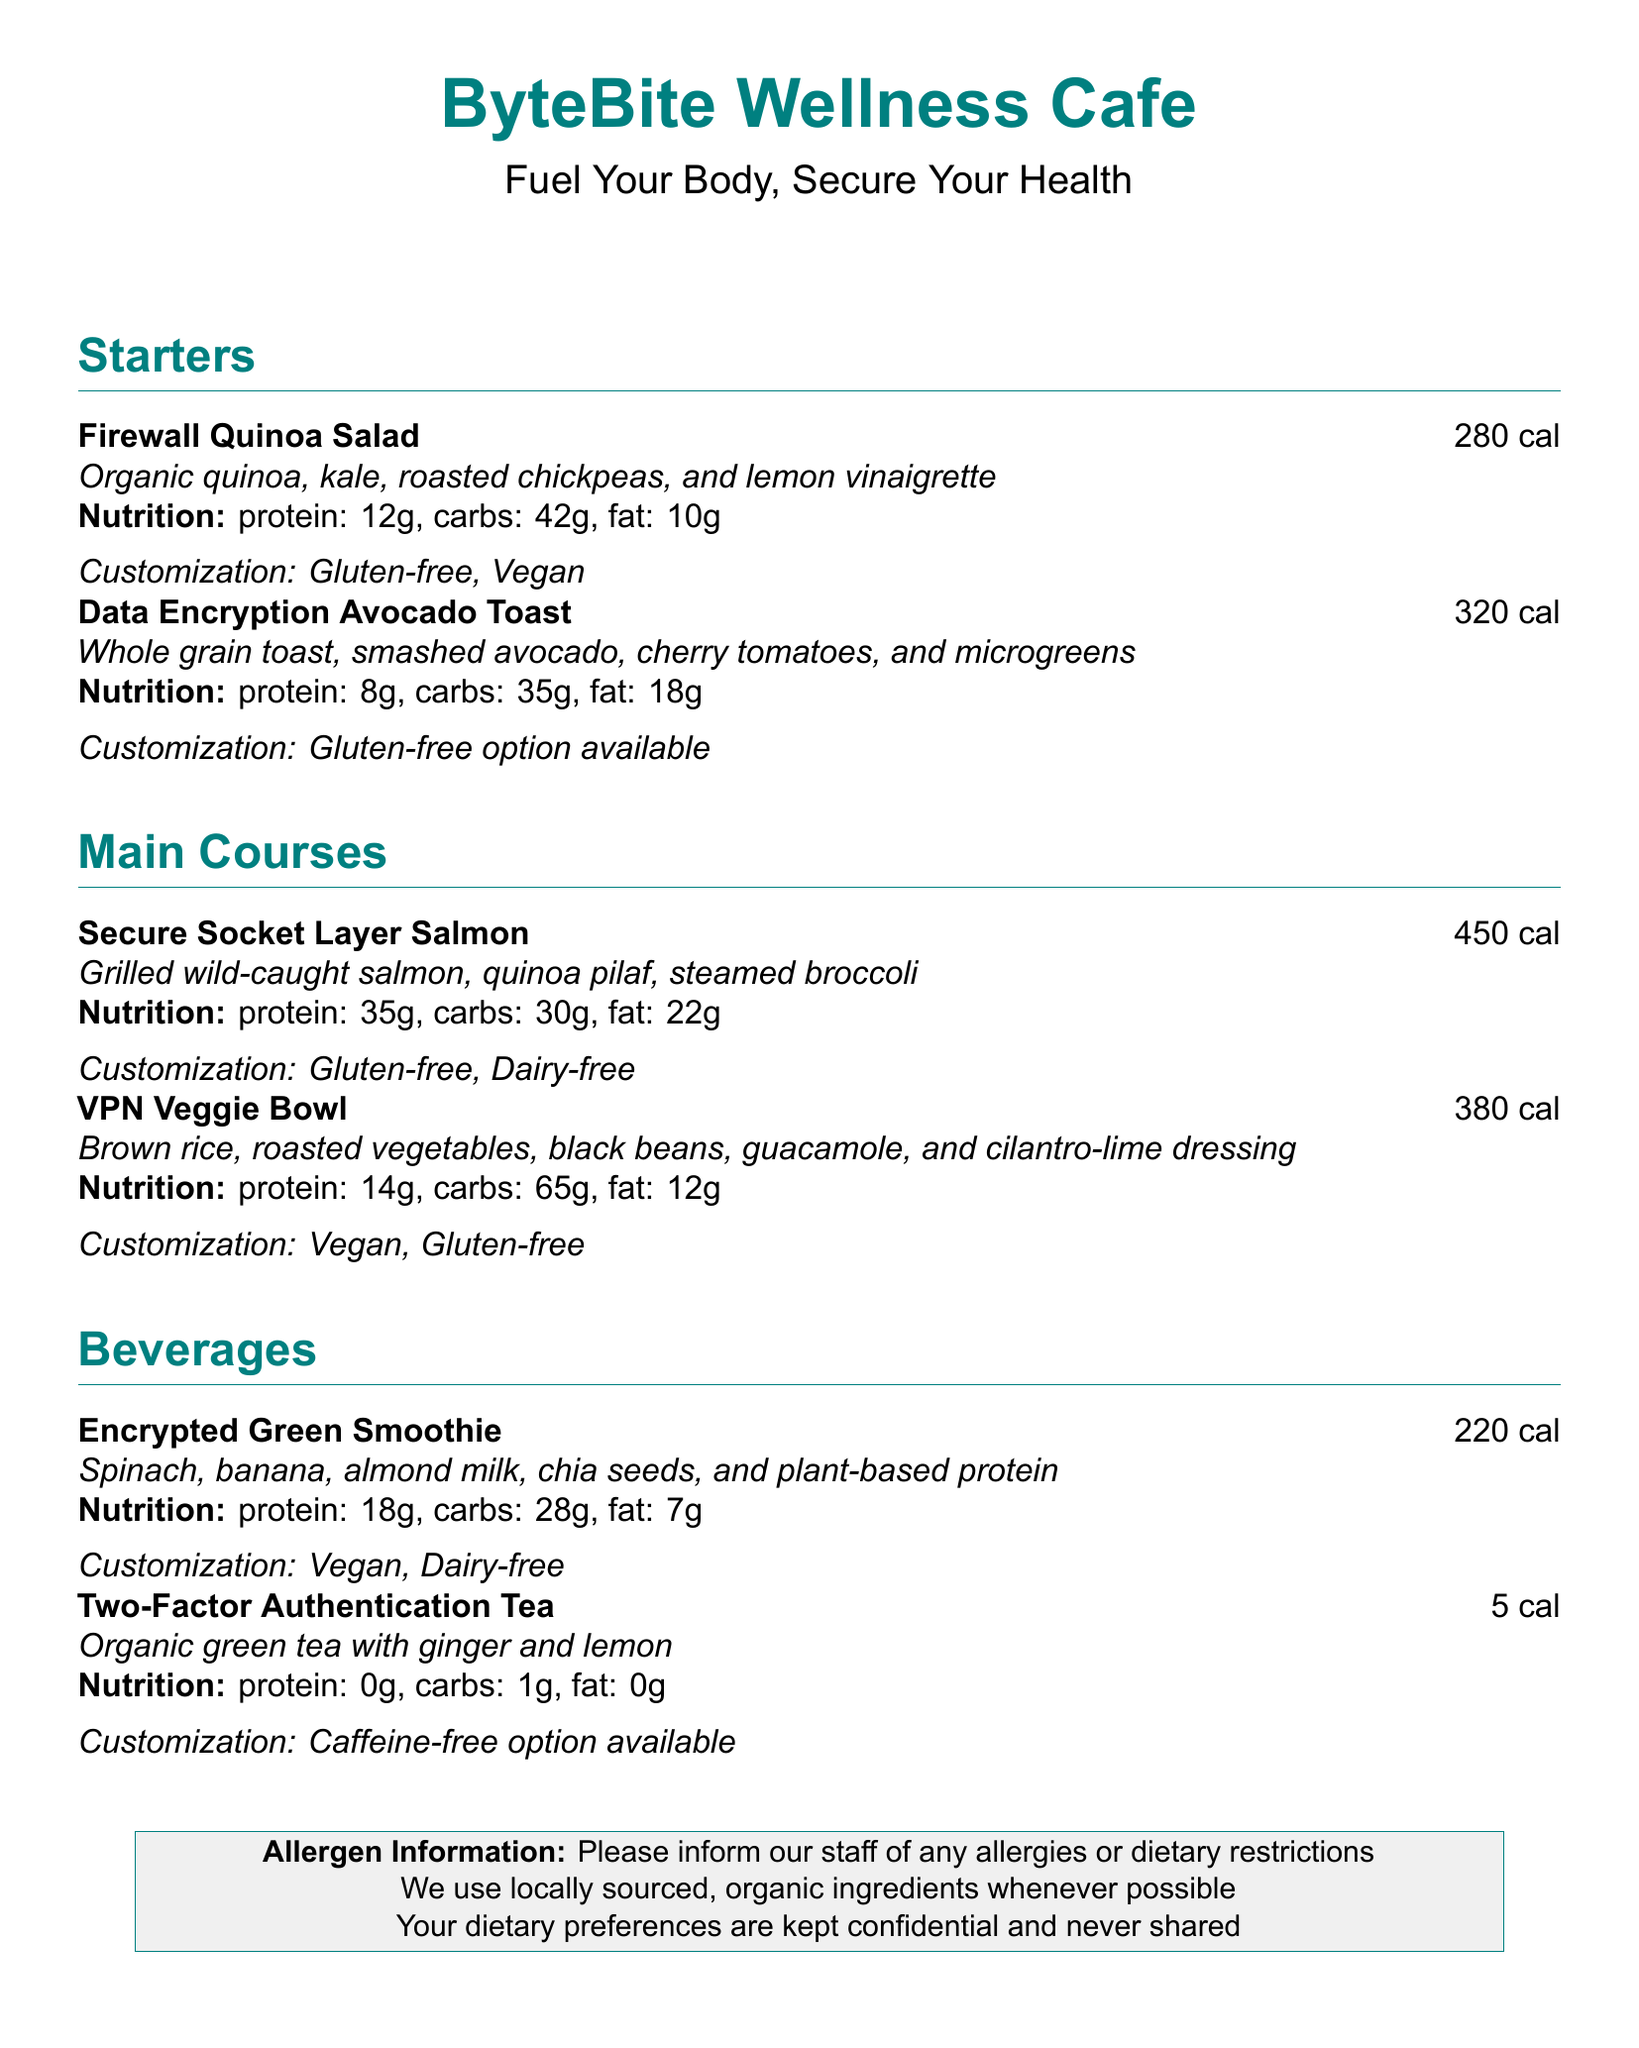What is the calorie count of the Firewall Quinoa Salad? The calorie count for the Firewall Quinoa Salad is provided in the document, which states it has 280 calories.
Answer: 280 cal What is the main protein source in the Secure Socket Layer Salmon? The description of the Secure Socket Layer Salmon mentions it is made with wild-caught salmon, which is the main protein source.
Answer: Salmon How many grams of protein are in the Encrypted Green Smoothie? The document provides nutritional information for each menu item, indicating that the Encrypted Green Smoothie has 18 grams of protein.
Answer: 18g Which dish is customizable to be dairy-free? The document states that the Secure Socket Layer Salmon can be customized to be dairy-free, making it the correct answer.
Answer: Secure Socket Layer Salmon What kind of tea is the Two-Factor Authentication Tea? The document clearly specifies that it is organic green tea, providing clear identification of the tea.
Answer: Organic green tea 